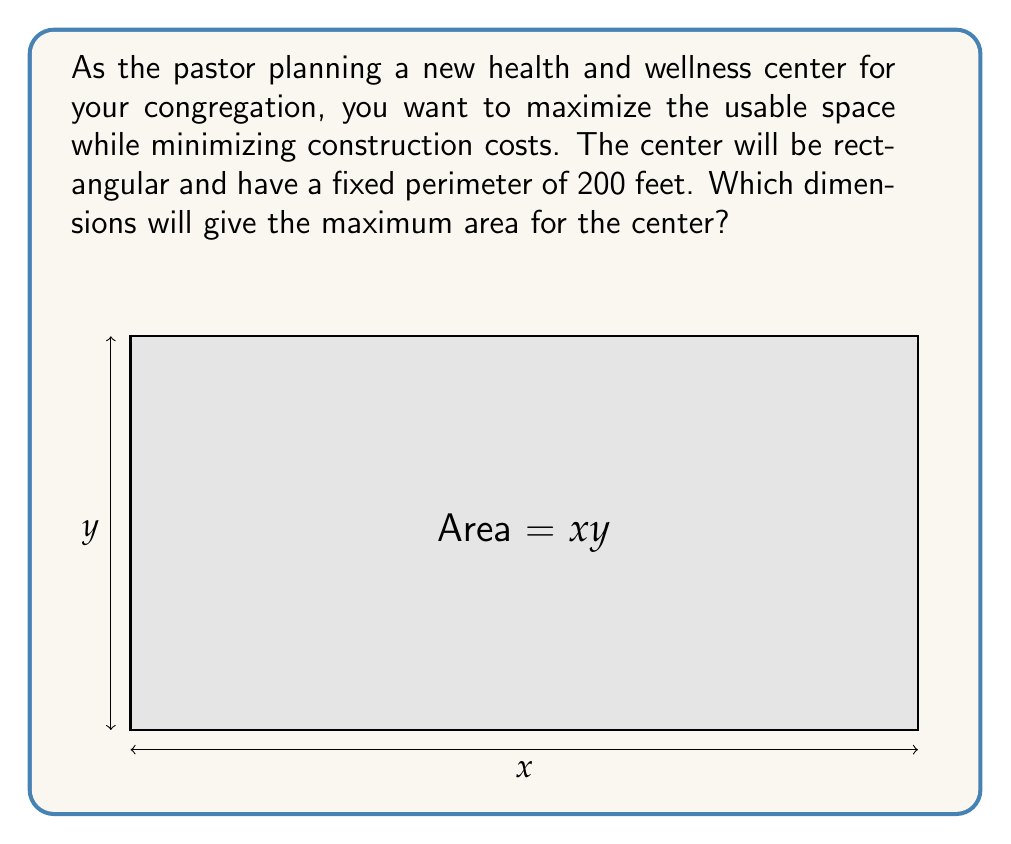Solve this math problem. Let's approach this step-by-step:

1) Let $x$ be the length and $y$ be the width of the rectangle.

2) Given the perimeter is 200 feet, we can write:
   $2x + 2y = 200$
   
3) Solving for $y$:
   $y = 100 - x$

4) The area of the rectangle is given by $A = xy$. Substituting $y$:
   $A = x(100 - x) = 100x - x^2$

5) To find the maximum area, we need to find where the derivative of $A$ with respect to $x$ is zero:
   $$\frac{dA}{dx} = 100 - 2x$$

6) Setting this equal to zero:
   $100 - 2x = 0$
   $2x = 100$
   $x = 50$

7) Since $y = 100 - x$, when $x = 50$, $y = 50$ as well.

8) To confirm this is a maximum (not a minimum), we can check the second derivative:
   $$\frac{d^2A}{dx^2} = -2$$
   This is negative, confirming we have found a maximum.

Therefore, the maximum area occurs when the length and width are both 50 feet, creating a square.
Answer: 50 feet by 50 feet 